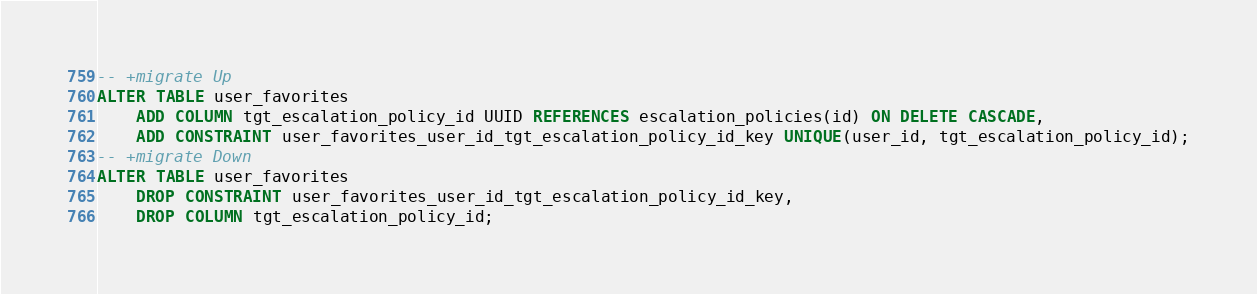<code> <loc_0><loc_0><loc_500><loc_500><_SQL_>-- +migrate Up
ALTER TABLE user_favorites
    ADD COLUMN tgt_escalation_policy_id UUID REFERENCES escalation_policies(id) ON DELETE CASCADE,
    ADD CONSTRAINT user_favorites_user_id_tgt_escalation_policy_id_key UNIQUE(user_id, tgt_escalation_policy_id);
-- +migrate Down
ALTER TABLE user_favorites
    DROP CONSTRAINT user_favorites_user_id_tgt_escalation_policy_id_key,
    DROP COLUMN tgt_escalation_policy_id;</code> 